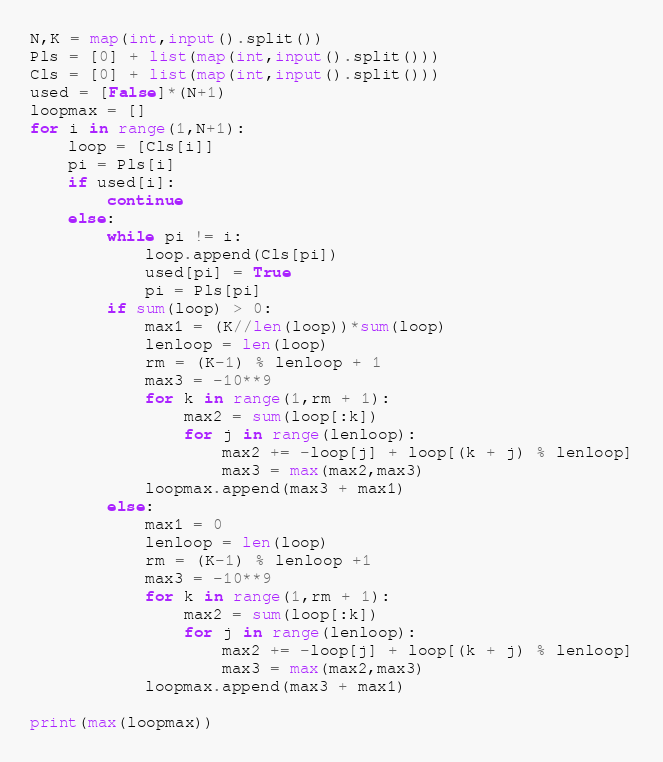<code> <loc_0><loc_0><loc_500><loc_500><_Python_>N,K = map(int,input().split())
Pls = [0] + list(map(int,input().split()))
Cls = [0] + list(map(int,input().split()))
used = [False]*(N+1)
loopmax = []
for i in range(1,N+1):
    loop = [Cls[i]]
    pi = Pls[i]
    if used[i]:
        continue
    else:
        while pi != i:
            loop.append(Cls[pi])
            used[pi] = True
            pi = Pls[pi]
        if sum(loop) > 0:
            max1 = (K//len(loop))*sum(loop)
            lenloop = len(loop)
            rm = (K-1) % lenloop + 1
            max3 = -10**9
            for k in range(1,rm + 1):
                max2 = sum(loop[:k])
                for j in range(lenloop):
                    max2 += -loop[j] + loop[(k + j) % lenloop]
                    max3 = max(max2,max3)
            loopmax.append(max3 + max1)
        else:
            max1 = 0
            lenloop = len(loop)
            rm = (K-1) % lenloop +1
            max3 = -10**9
            for k in range(1,rm + 1):
                max2 = sum(loop[:k])
                for j in range(lenloop):
                    max2 += -loop[j] + loop[(k + j) % lenloop]
                    max3 = max(max2,max3)
            loopmax.append(max3 + max1)

print(max(loopmax))
</code> 